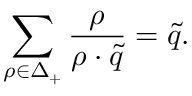<formula> <loc_0><loc_0><loc_500><loc_500>\sum _ { \rho \in \Delta _ { + } } { \frac { \rho } { \rho \cdot \tilde { q } } } = \tilde { q } .</formula> 